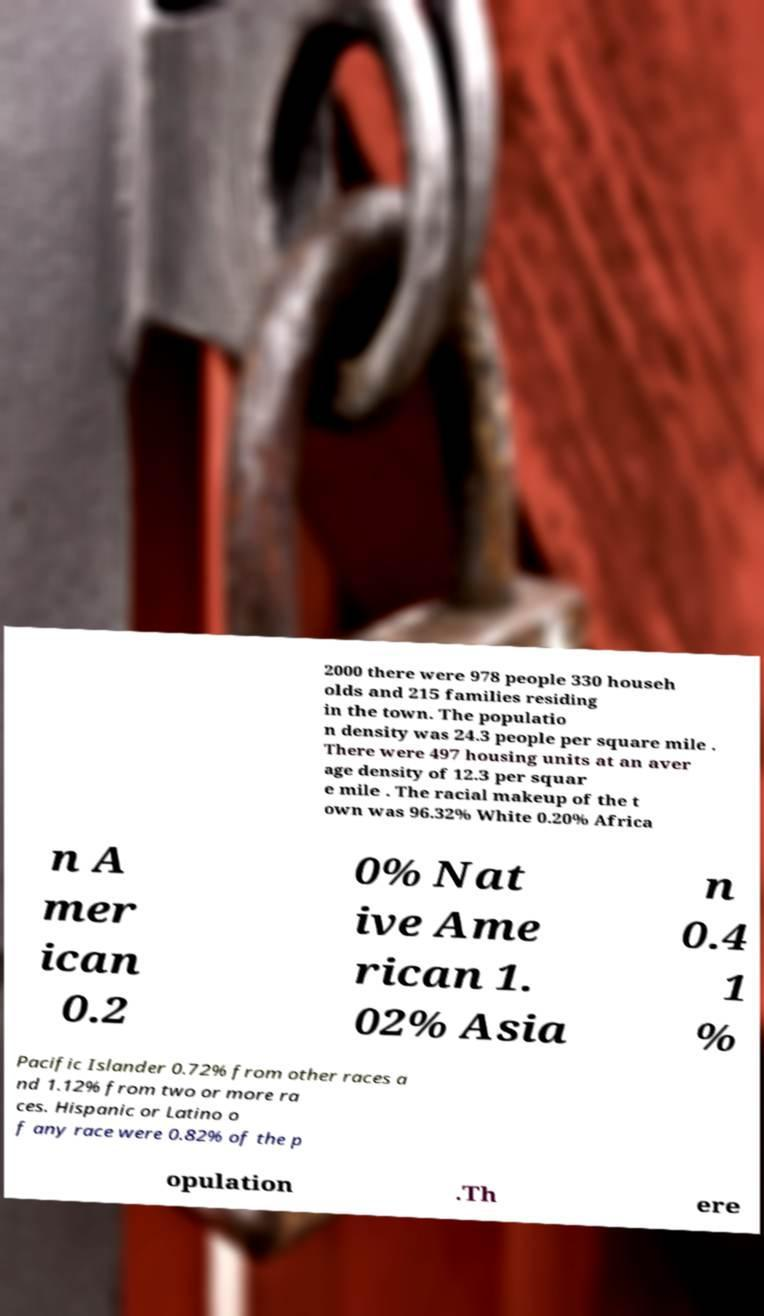There's text embedded in this image that I need extracted. Can you transcribe it verbatim? 2000 there were 978 people 330 househ olds and 215 families residing in the town. The populatio n density was 24.3 people per square mile . There were 497 housing units at an aver age density of 12.3 per squar e mile . The racial makeup of the t own was 96.32% White 0.20% Africa n A mer ican 0.2 0% Nat ive Ame rican 1. 02% Asia n 0.4 1 % Pacific Islander 0.72% from other races a nd 1.12% from two or more ra ces. Hispanic or Latino o f any race were 0.82% of the p opulation .Th ere 